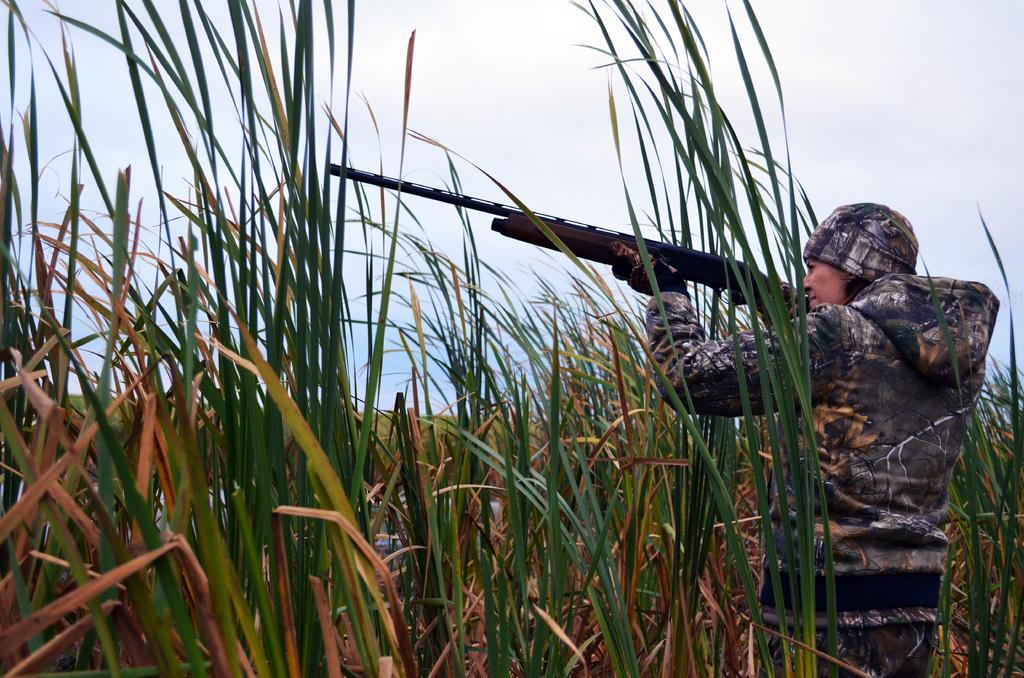Who is the main subject in the image? There is a woman in the image. What is the woman doing in the image? The woman is standing in the image. What is the woman holding in her hands? The woman is holding a weapon in her hands. Can you describe the woman's clothing in the image? The woman is wearing a cap, a jerkin, gloves, and trousers in the image. What can be seen in the background of the image? The background appears to be grass. What type of food is being advertised in the image? There is no advertisement or food present in the image; it features a woman standing with a weapon. Can you tell me what the woman's father looks like in the image? There is no father or any other person present in the image; it only features the woman. 